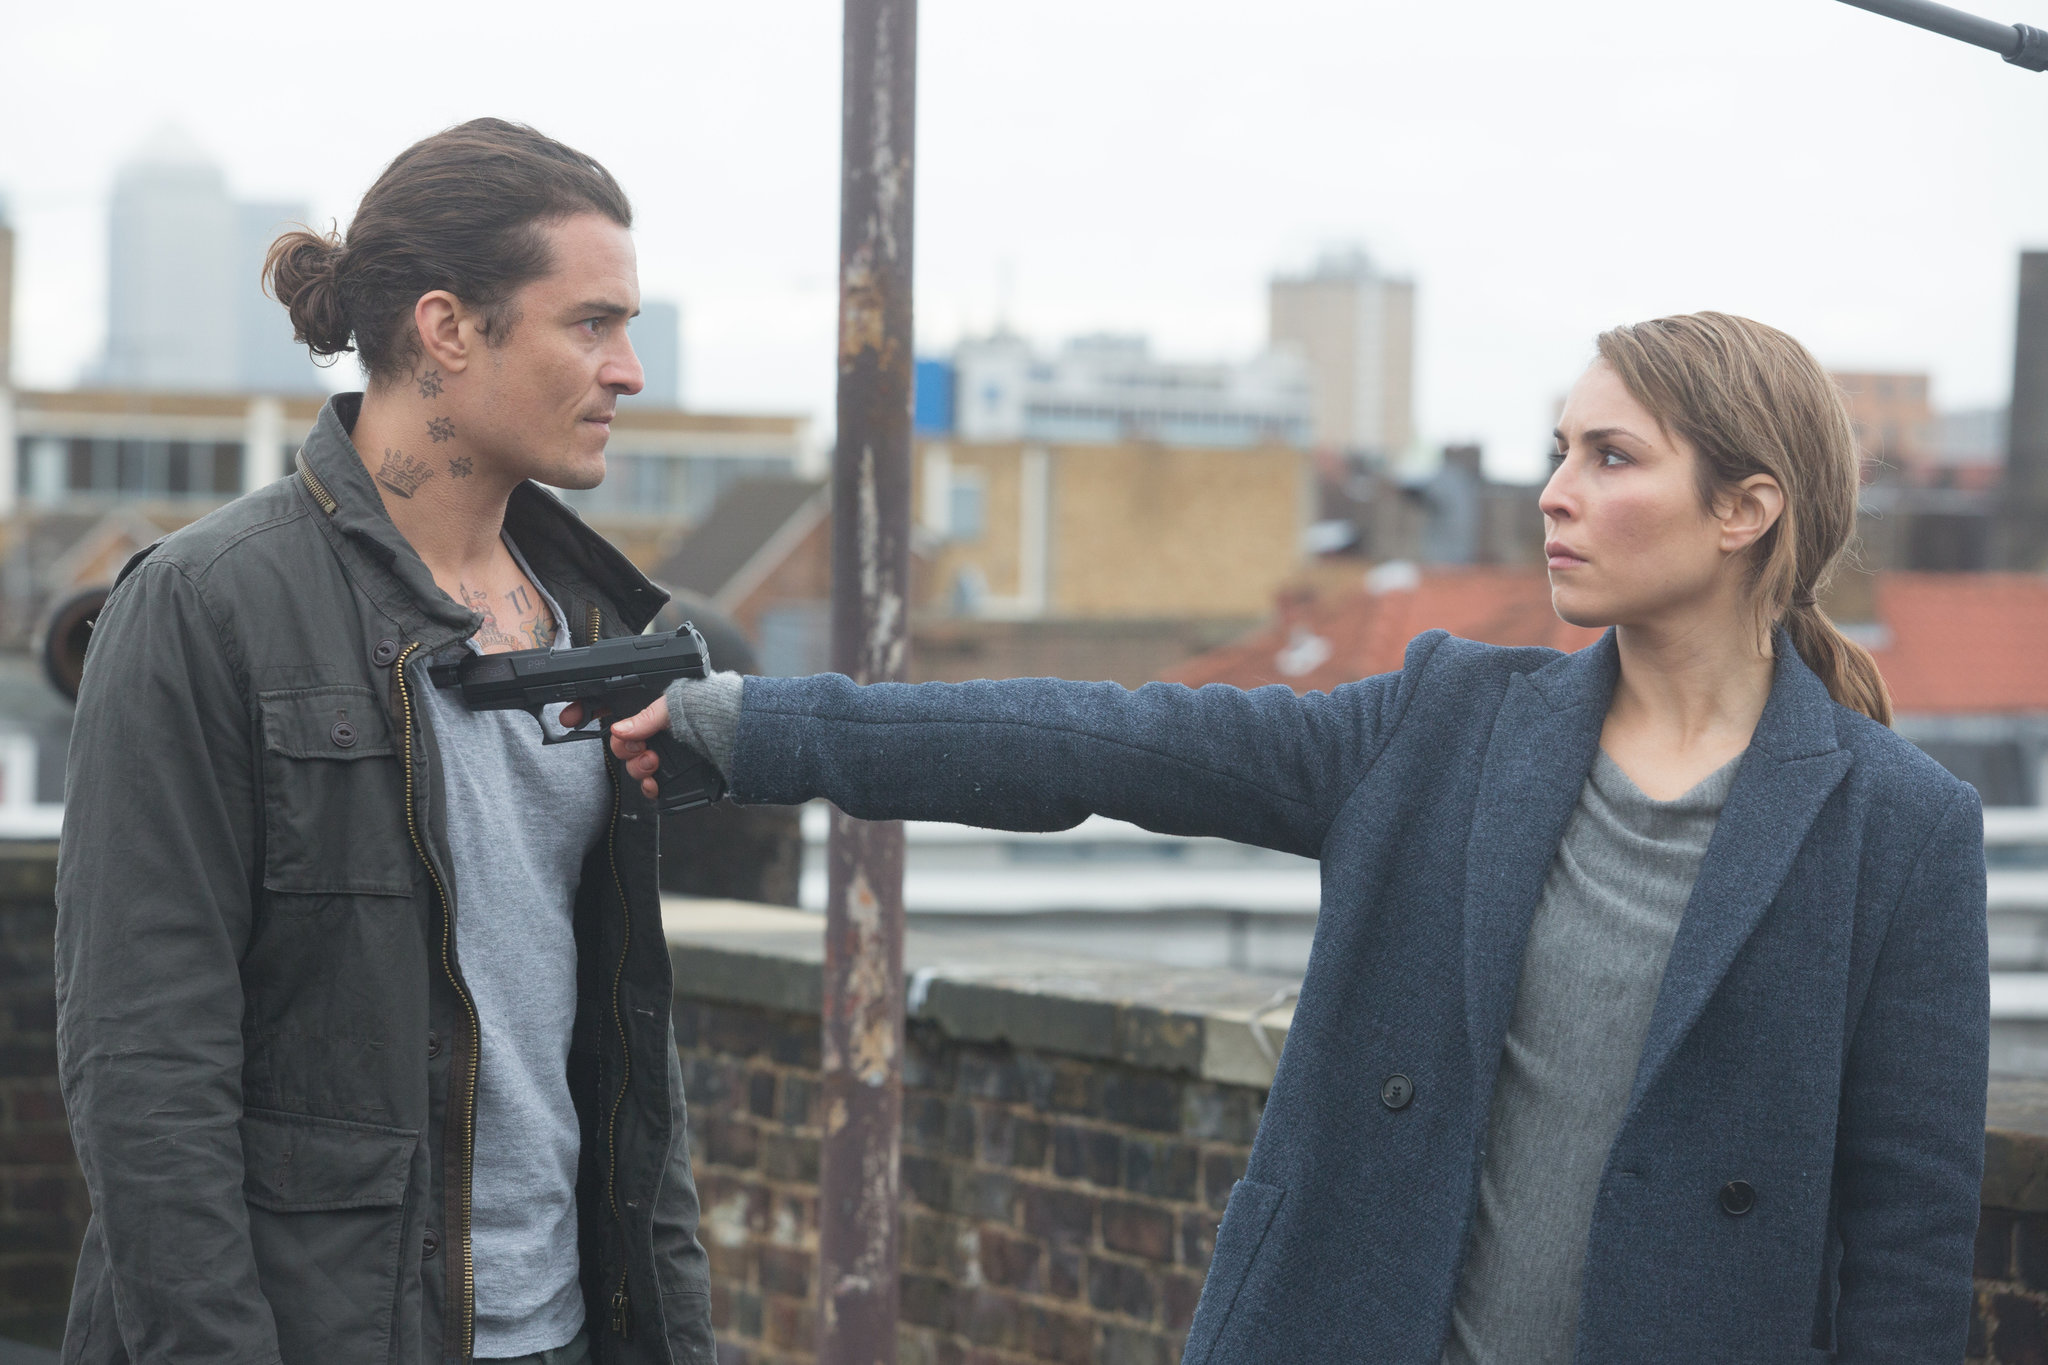What could be the background story leading to this scene? The background story leading to this rooftop confrontation might involve a series of escalating events. sharegpt4v/sam, the character pointing the gun, could be a professional with a specific mission or a personal vendetta against the man in the green jacket. Considering the tension and high stakes reflected in this moment, there might have been previous encounters where the man, who appears to have an air of defiance or calm under pressure, wronged sharegpt4v/sam or was directly involved in a significant conflict in her life. Each tattoo on his neck could symbolize a past crime or trauma, adding depth to his character. Their paths crossing on this rooftop hints at a climactic face-off, possibly orchestrated by a deeper narrative involving deceit, survival, or retribution. 